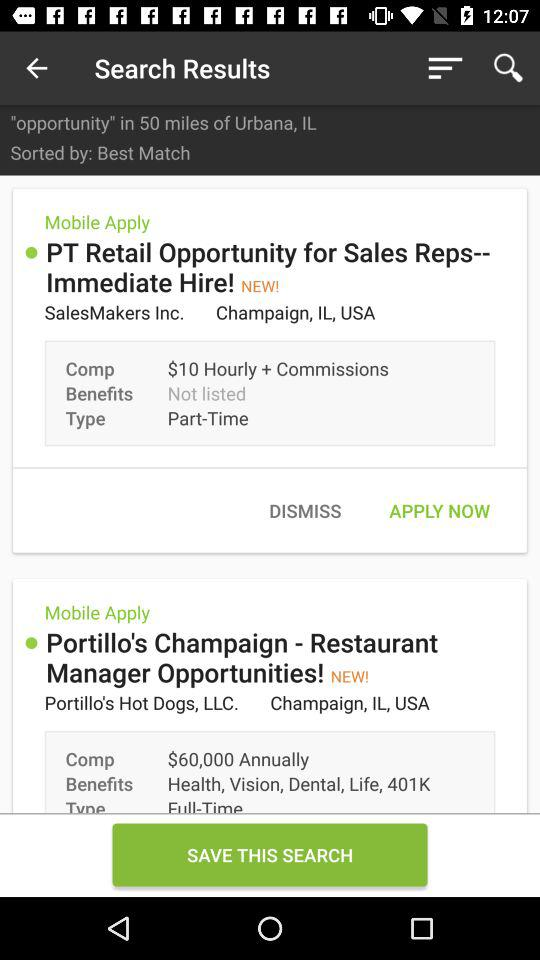How are the search results sorted? The search results are sorted by best match. 